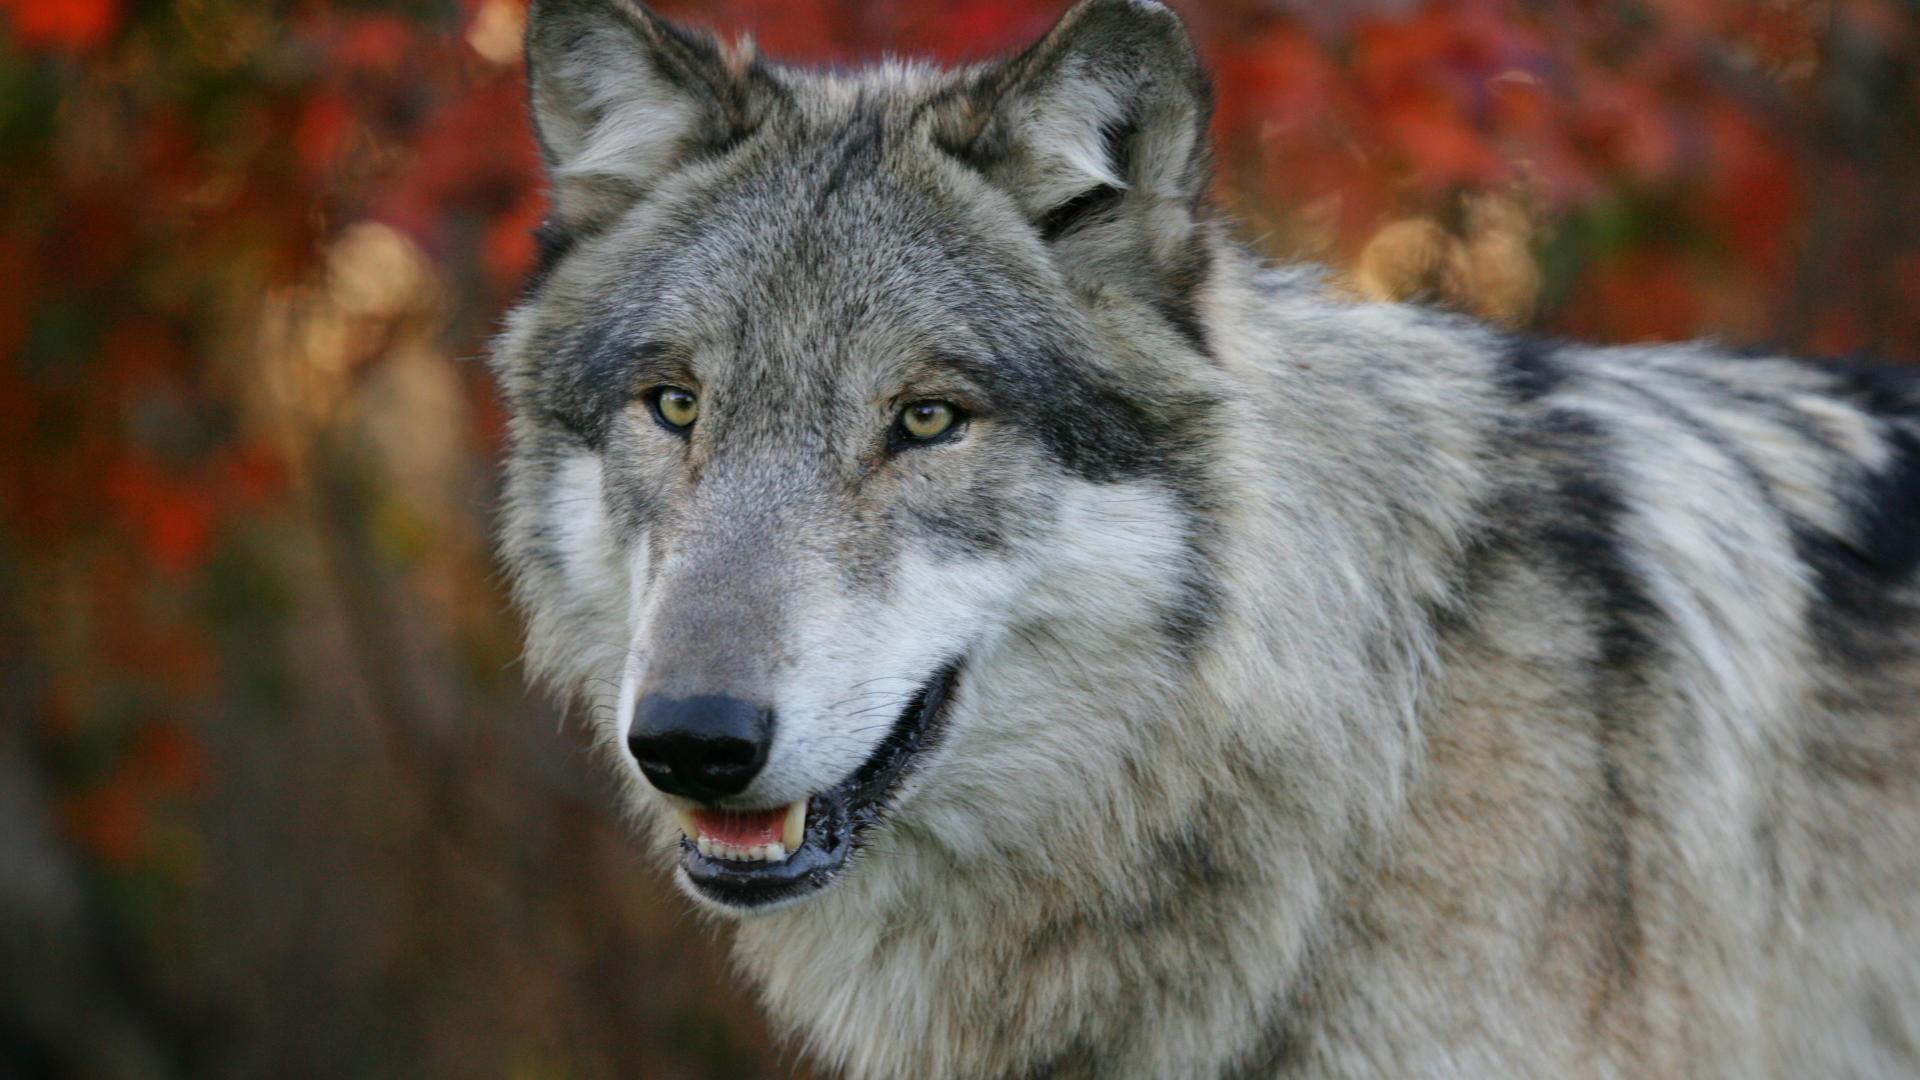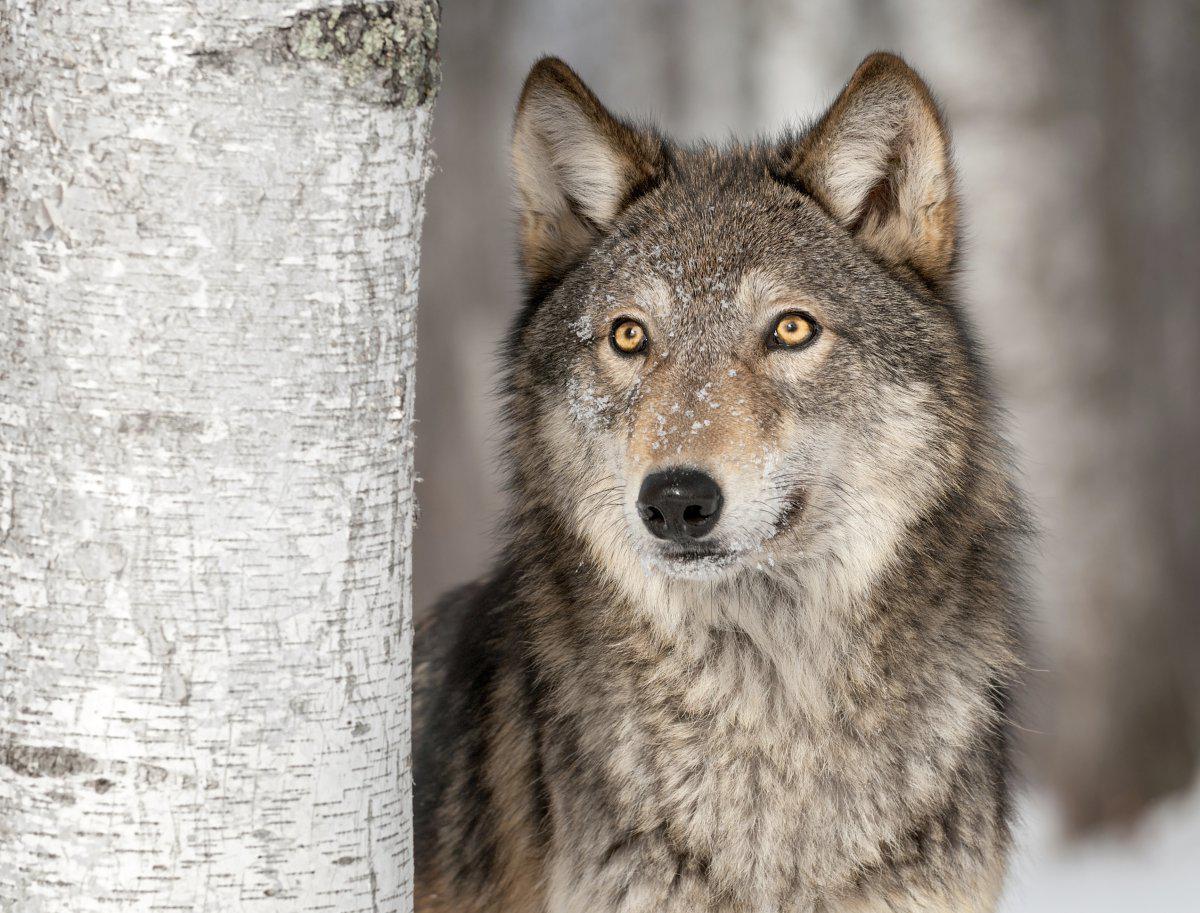The first image is the image on the left, the second image is the image on the right. Examine the images to the left and right. Is the description "In the center of each image a wolf can be seen in the outdoors." accurate? Answer yes or no. Yes. The first image is the image on the left, the second image is the image on the right. Given the left and right images, does the statement "Each image contains one forward-turned wolf with its head held straight and level, and the gazes of the wolves on the right and left are aimed in the same direction." hold true? Answer yes or no. Yes. 